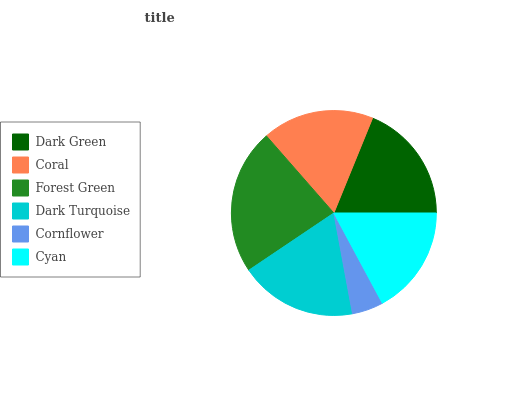Is Cornflower the minimum?
Answer yes or no. Yes. Is Forest Green the maximum?
Answer yes or no. Yes. Is Coral the minimum?
Answer yes or no. No. Is Coral the maximum?
Answer yes or no. No. Is Dark Green greater than Coral?
Answer yes or no. Yes. Is Coral less than Dark Green?
Answer yes or no. Yes. Is Coral greater than Dark Green?
Answer yes or no. No. Is Dark Green less than Coral?
Answer yes or no. No. Is Dark Turquoise the high median?
Answer yes or no. Yes. Is Coral the low median?
Answer yes or no. Yes. Is Coral the high median?
Answer yes or no. No. Is Dark Turquoise the low median?
Answer yes or no. No. 